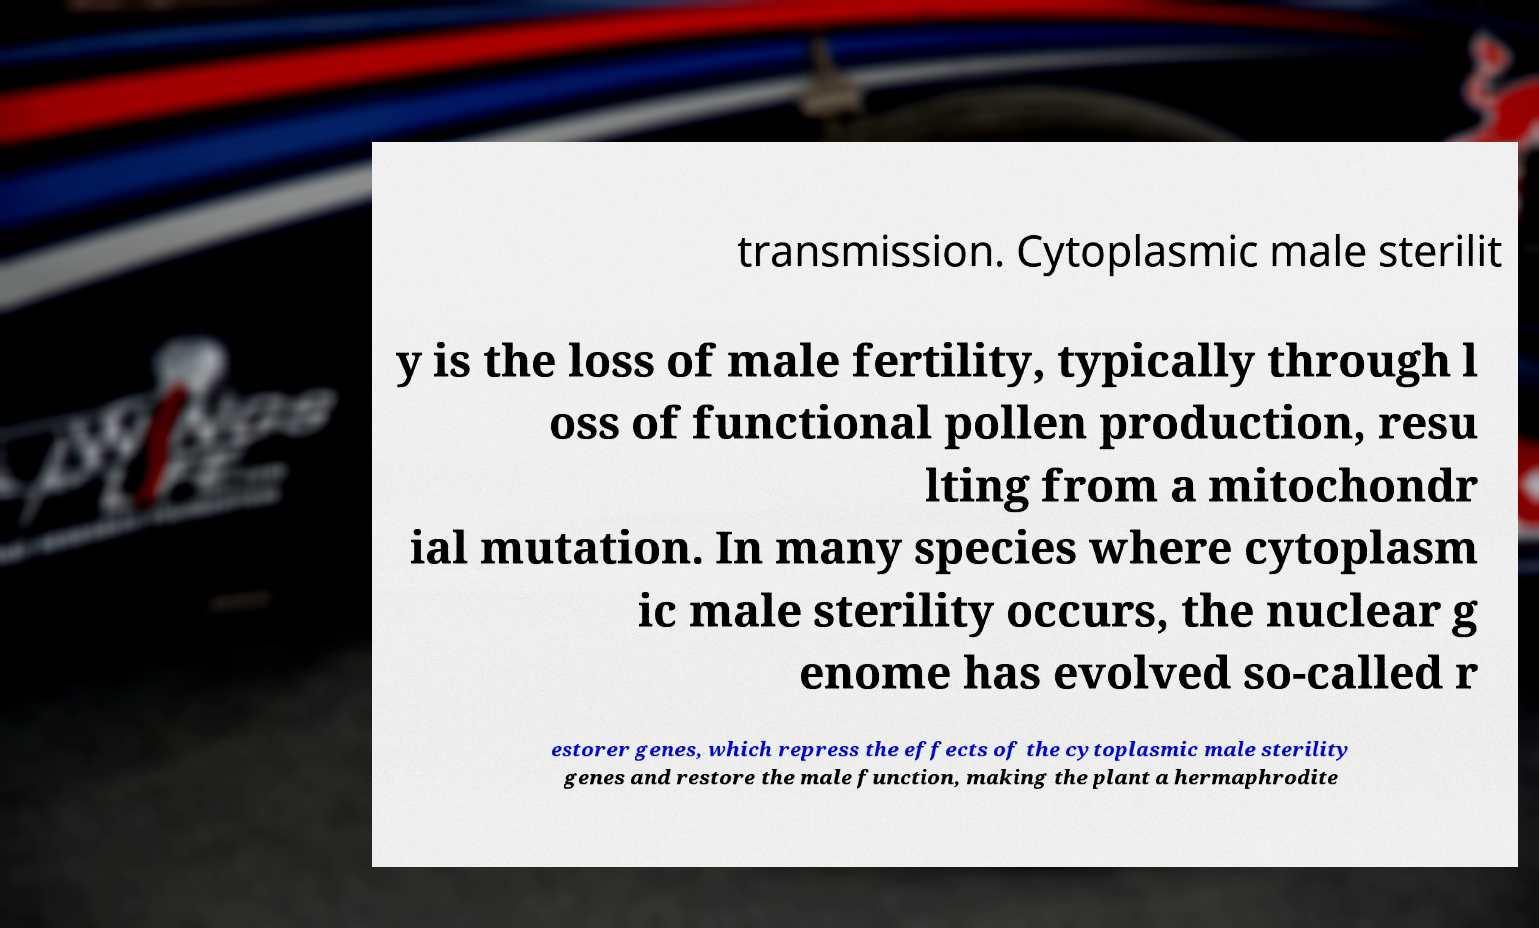Can you read and provide the text displayed in the image?This photo seems to have some interesting text. Can you extract and type it out for me? transmission. Cytoplasmic male sterilit y is the loss of male fertility, typically through l oss of functional pollen production, resu lting from a mitochondr ial mutation. In many species where cytoplasm ic male sterility occurs, the nuclear g enome has evolved so-called r estorer genes, which repress the effects of the cytoplasmic male sterility genes and restore the male function, making the plant a hermaphrodite 